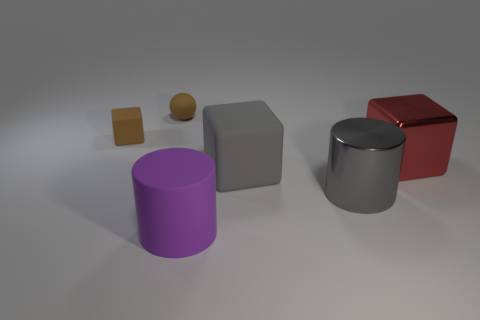What shape is the shiny thing that is the same color as the big matte cube?
Provide a succinct answer. Cylinder. What number of other objects are the same shape as the red metallic thing?
Give a very brief answer. 2. The large thing that is made of the same material as the purple cylinder is what shape?
Make the answer very short. Cube. There is a block in front of the big block that is to the right of the large shiny object in front of the big metallic block; what is its material?
Give a very brief answer. Rubber. There is a gray shiny cylinder; is its size the same as the brown thing that is left of the tiny sphere?
Your answer should be very brief. No. There is a purple object that is the same shape as the gray metallic thing; what is it made of?
Your answer should be compact. Rubber. How big is the rubber block left of the rubber block that is in front of the rubber cube that is to the left of the big gray cube?
Give a very brief answer. Small. Is the brown ball the same size as the gray block?
Make the answer very short. No. What material is the cylinder on the right side of the cube that is in front of the large red thing made of?
Keep it short and to the point. Metal. There is a big matte thing that is behind the purple object; is it the same shape as the shiny thing that is left of the red metal thing?
Give a very brief answer. No. 